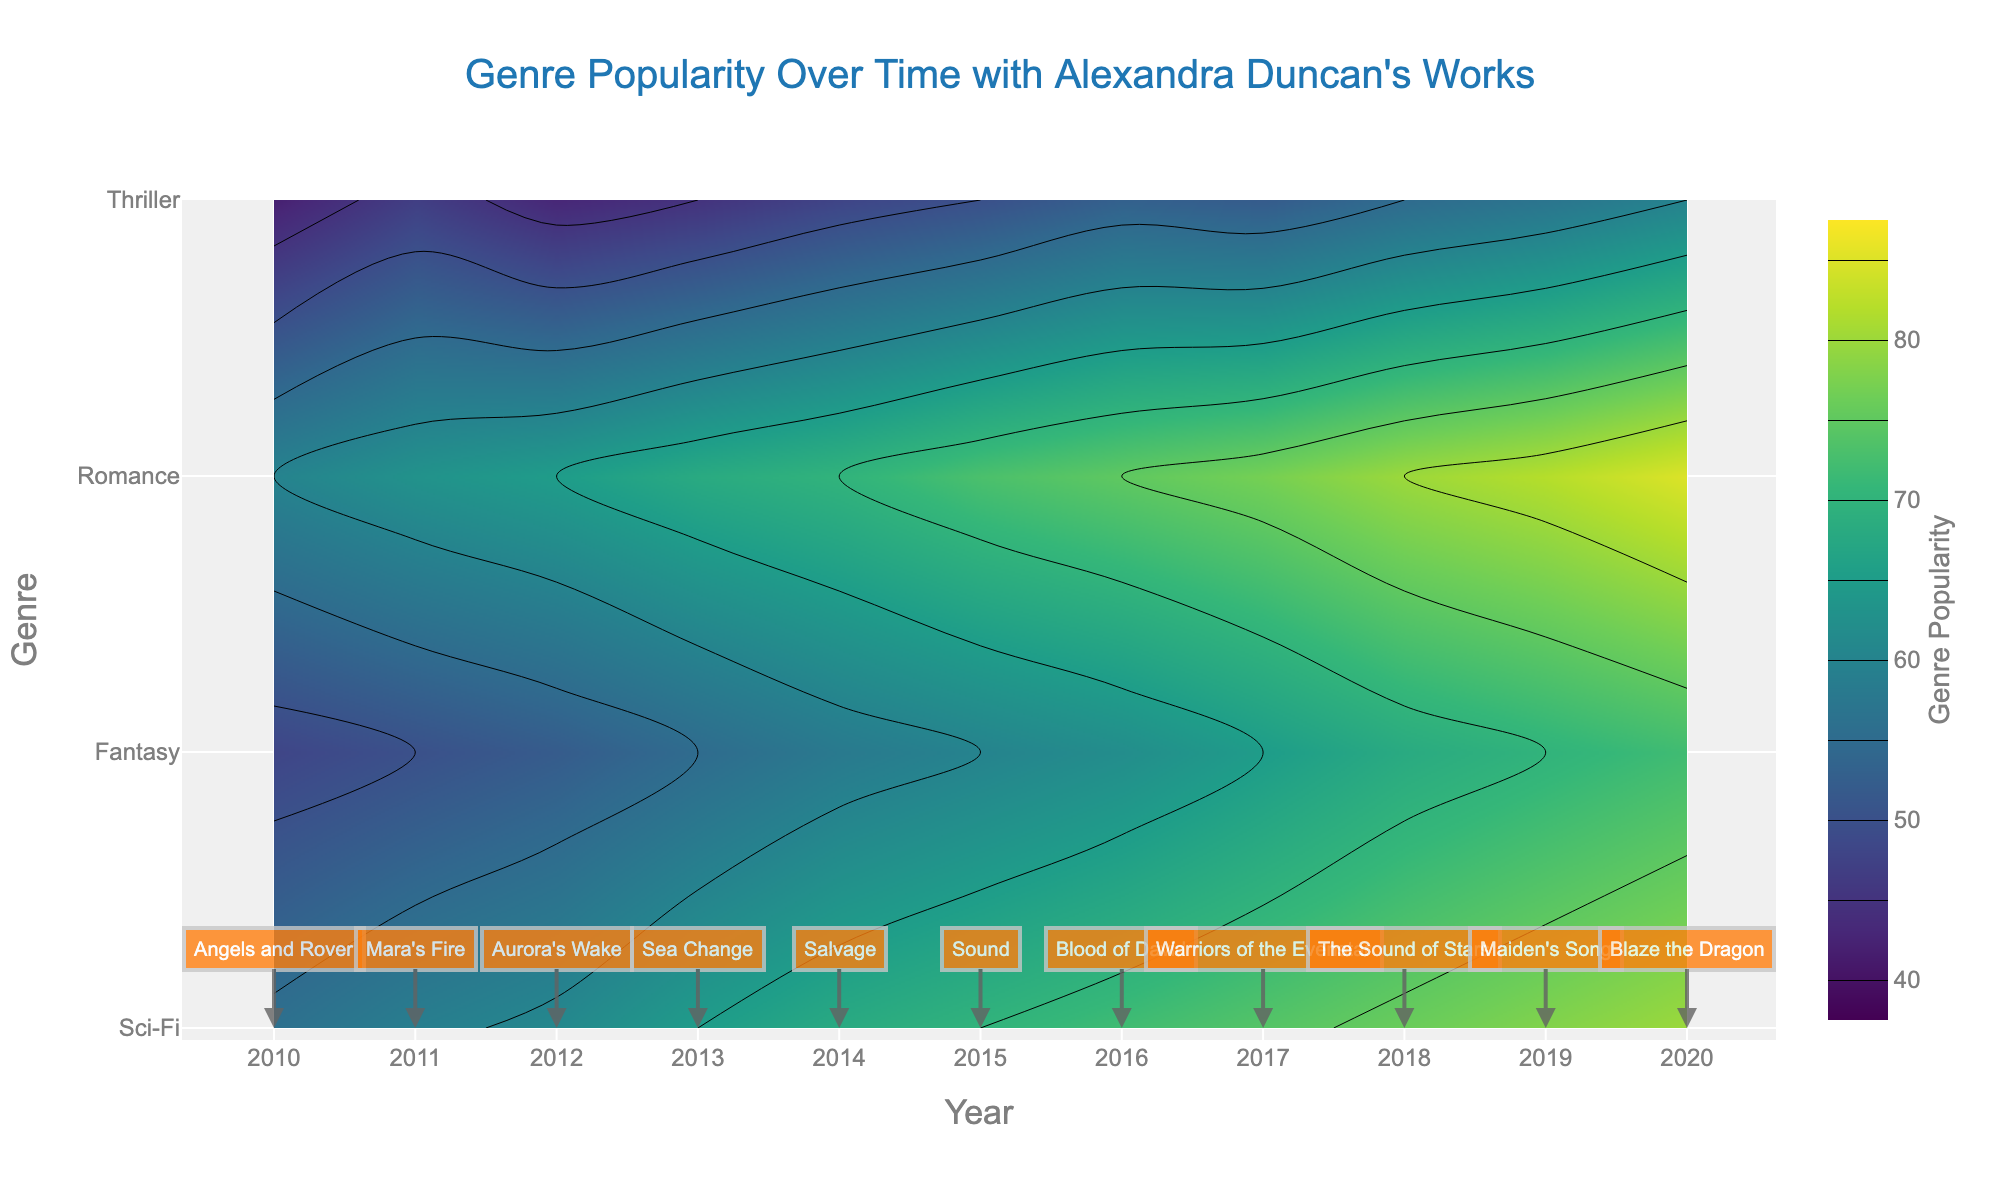What is the title of the plot? The title of the plot is generally placed at the top center and clearly visible in a larger font.
Answer: Genre Popularity Over Time with Alexandra Duncan's Works Which year has the highest popularity for the Sci-Fi genre? To find this, locate the Sci-Fi row on the y-axis and find the highest contour level along the x-axis (years).
Answer: 2020 What genre had the lowest popularity in 2013? Look at the 2013 position on the x-axis and compare the contour levels of each genre at this year.
Answer: Thriller Which genre’s popularity increased the most from 2010 to 2020? Compare the starting and ending values of the contour lines for each genre from 2010 to 2020. The largest difference indicates the most increased popularity.
Answer: Romance How is the popularity trend of Fantasy from 2010 to 2020? Observe the contour levels along the Fantasy row from 2010 to 2020.
Answer: Increasing What was the popularity level of the Romance genre in 2015? Locate the 2015 mark on the x-axis and find the corresponding contour level for Romance.
Answer: 73 In which year did Alexandra Duncan release the book "Blood of David"? Annotations with book titles are placed on top of contour lines; find "Blood of David" and check its position on the x-axis.
Answer: 2016 How many genres had a popularity score above 70 in 2017? Check the 2017 position on the x-axis and count the number of genres with contour levels above 70.
Answer: 3 Does the Thriller genre ever surpass 60 in popularity? Check the highest contour level (top contour line) for the Thriller genre throughout the years.
Answer: No Compare the popularity between Sci-Fi and Fantasy in 2011. Which one is higher? Look at the 2011 mark on the x-axis and compare the contour lines of Sci-Fi and Fantasy.
Answer: Sci-Fi 